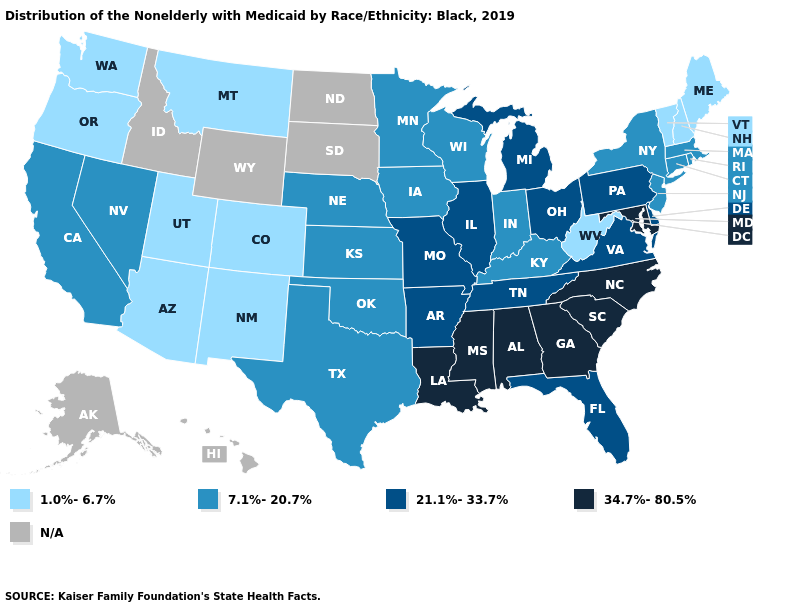Name the states that have a value in the range N/A?
Concise answer only. Alaska, Hawaii, Idaho, North Dakota, South Dakota, Wyoming. Name the states that have a value in the range 34.7%-80.5%?
Be succinct. Alabama, Georgia, Louisiana, Maryland, Mississippi, North Carolina, South Carolina. What is the lowest value in states that border New Mexico?
Give a very brief answer. 1.0%-6.7%. Does the first symbol in the legend represent the smallest category?
Be succinct. Yes. What is the value of Connecticut?
Write a very short answer. 7.1%-20.7%. Among the states that border Iowa , does Missouri have the highest value?
Answer briefly. Yes. Does the map have missing data?
Write a very short answer. Yes. What is the value of Arizona?
Give a very brief answer. 1.0%-6.7%. Which states have the highest value in the USA?
Keep it brief. Alabama, Georgia, Louisiana, Maryland, Mississippi, North Carolina, South Carolina. How many symbols are there in the legend?
Write a very short answer. 5. Name the states that have a value in the range 21.1%-33.7%?
Be succinct. Arkansas, Delaware, Florida, Illinois, Michigan, Missouri, Ohio, Pennsylvania, Tennessee, Virginia. Does Oregon have the lowest value in the USA?
Give a very brief answer. Yes. What is the value of Alaska?
Short answer required. N/A. What is the lowest value in the West?
Concise answer only. 1.0%-6.7%. Which states have the highest value in the USA?
Keep it brief. Alabama, Georgia, Louisiana, Maryland, Mississippi, North Carolina, South Carolina. 